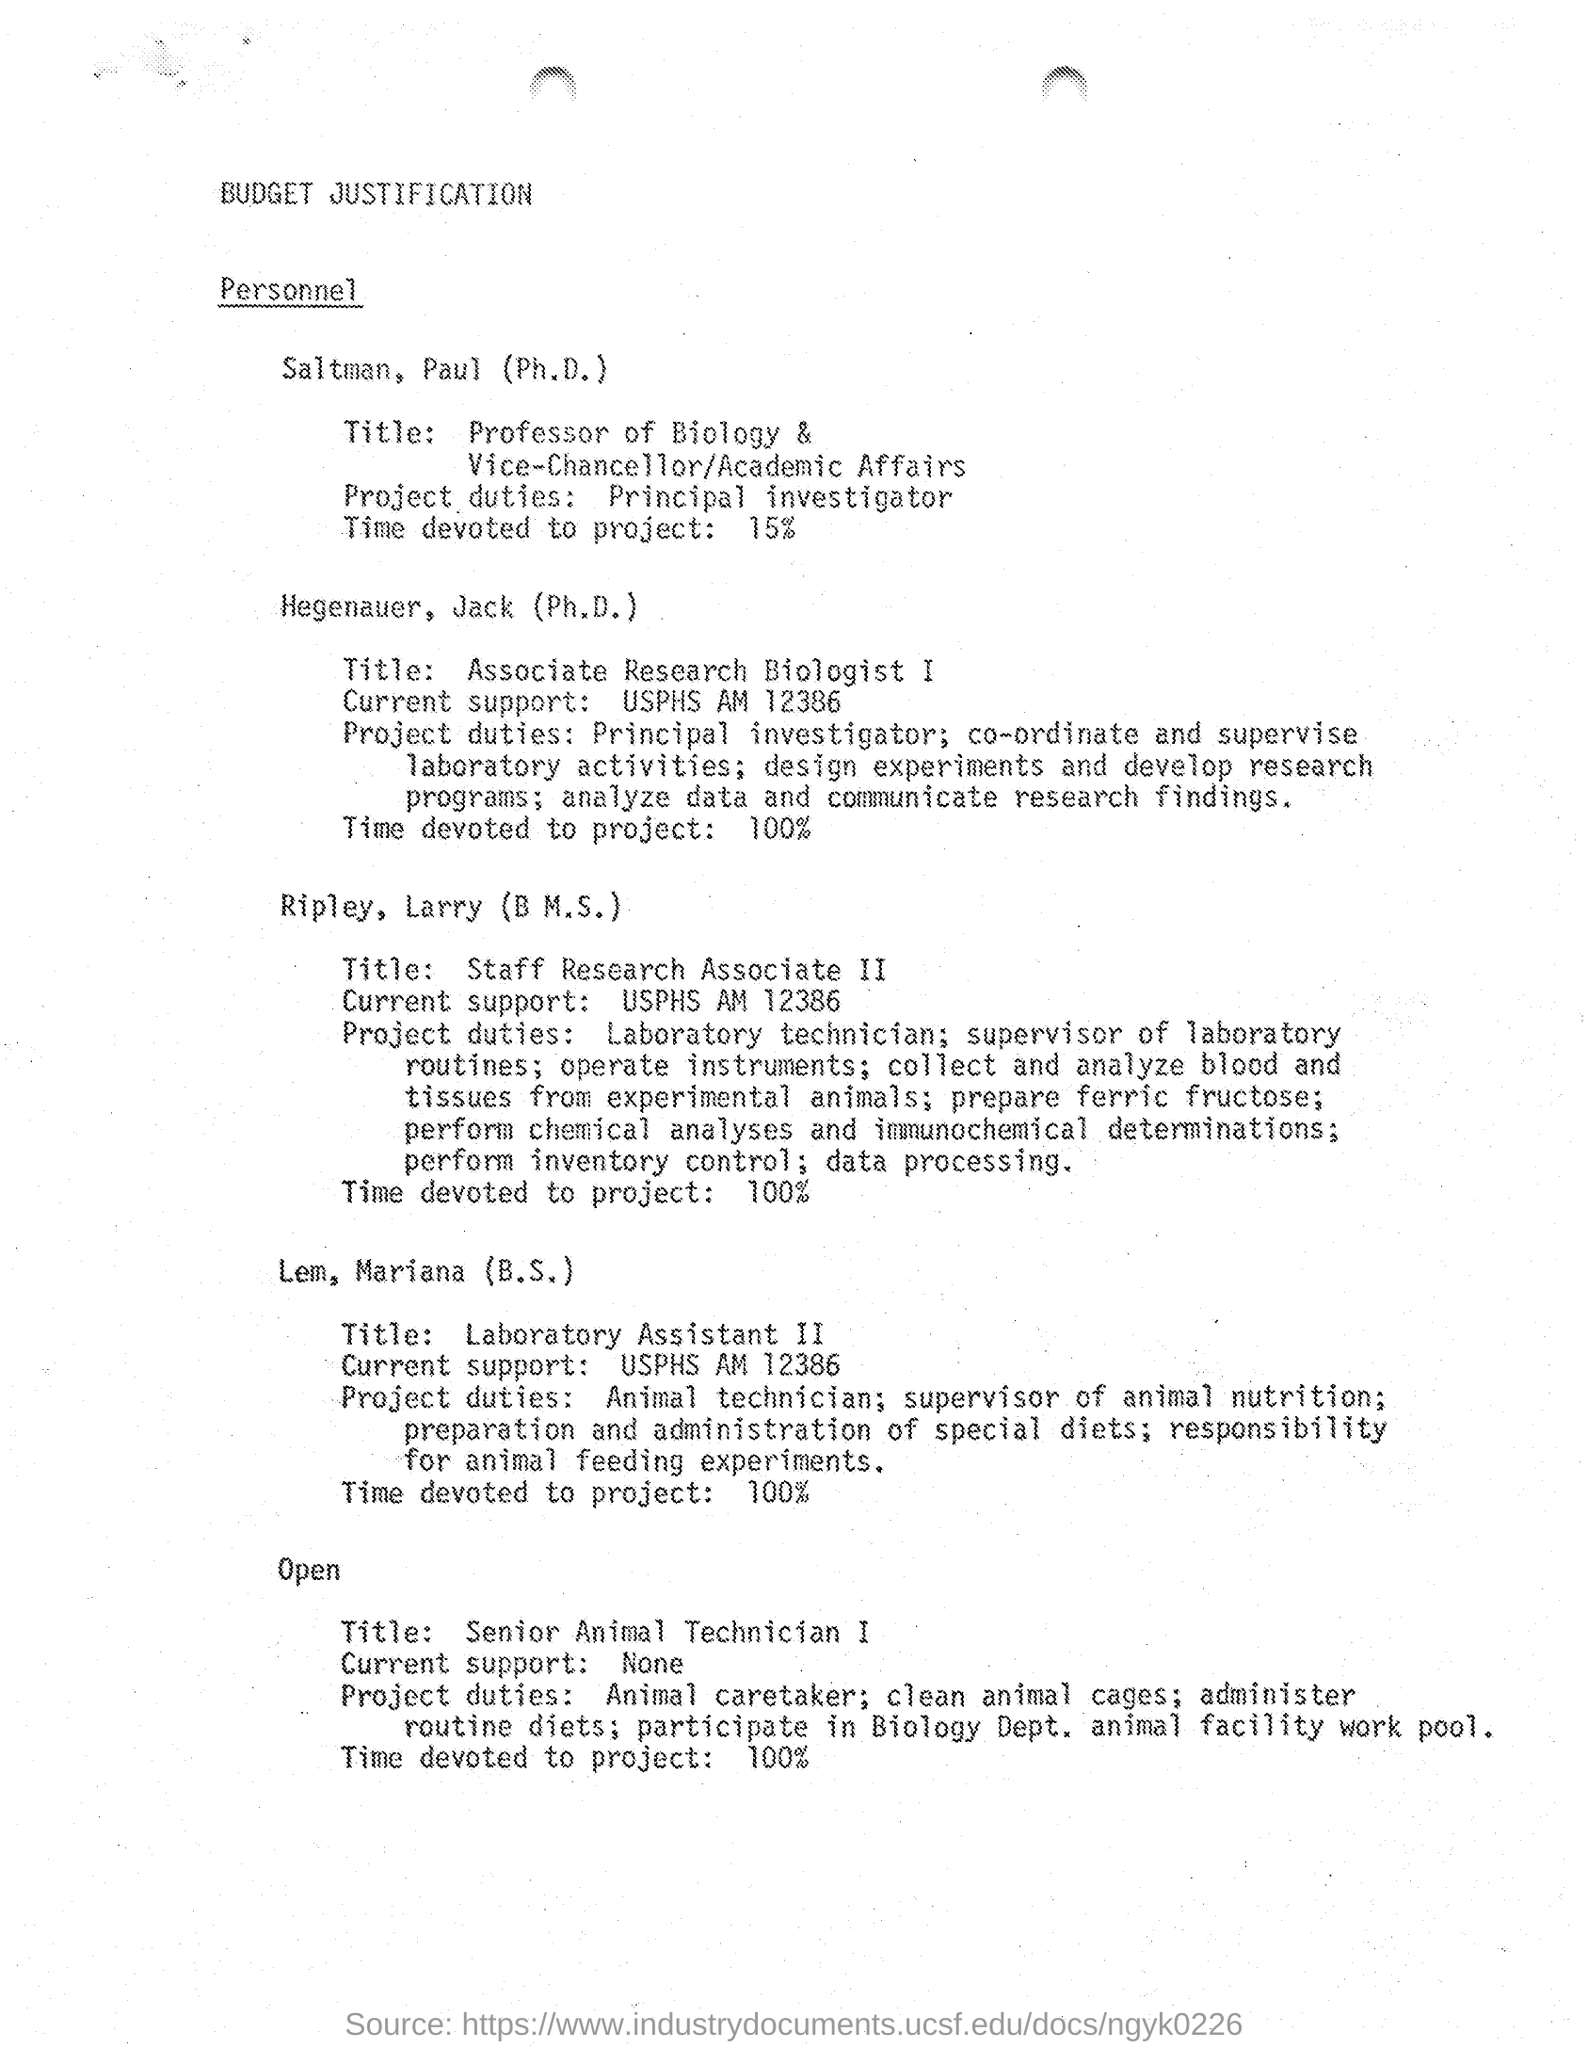What is the Job title of Saltman, Paul (Ph.D.)?
Provide a succinct answer. Professor of Biology & Vice-Chancellor/Academic Affairs. What is the project duty of Saltman, Paul (Ph.D.)?
Provide a short and direct response. Principal Investigator. How much time is devoted to the project by Saltman, Paul (Ph.D.)?
Your answer should be very brief. 15. What is the job title of Hegenauer, Jack (Ph. D.)?
Your answer should be very brief. Associate Research Biologist I. How much time is devoted to the project by Hegenauer, Jack (Ph. D.)?
Your answer should be compact. 100%. What is the job title of Ripley, Larry (B.M.S)?
Give a very brief answer. Staff Research Associate II. How much time is devoted to the project by Ripley, Larry (B.M.S)?
Give a very brief answer. 100%. What is the job title of Lem, Mariana (B.S)?
Offer a terse response. Laboratory Assistant II. 